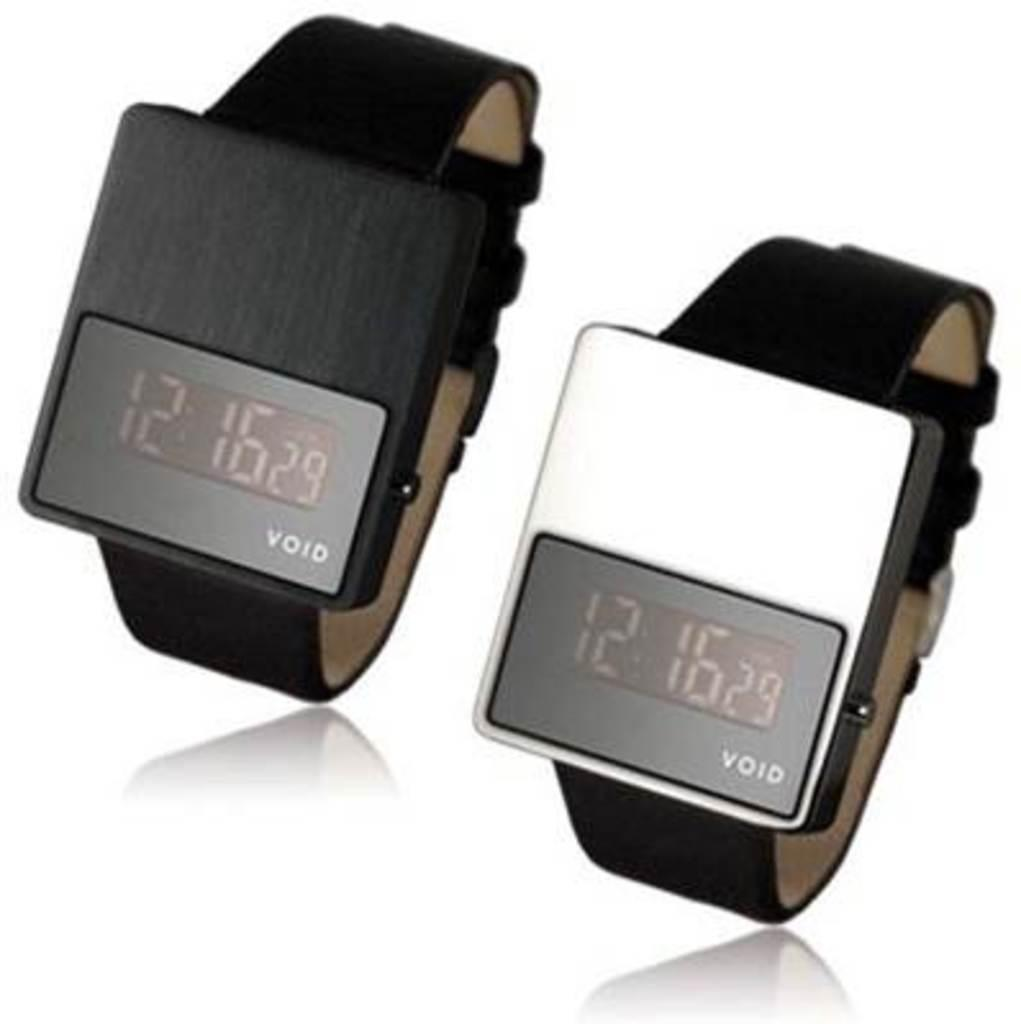Provide a one-sentence caption for the provided image. Two Void watches are next to each other and both read 12:16. 